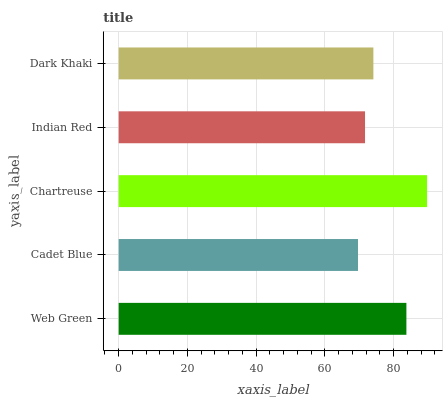Is Cadet Blue the minimum?
Answer yes or no. Yes. Is Chartreuse the maximum?
Answer yes or no. Yes. Is Chartreuse the minimum?
Answer yes or no. No. Is Cadet Blue the maximum?
Answer yes or no. No. Is Chartreuse greater than Cadet Blue?
Answer yes or no. Yes. Is Cadet Blue less than Chartreuse?
Answer yes or no. Yes. Is Cadet Blue greater than Chartreuse?
Answer yes or no. No. Is Chartreuse less than Cadet Blue?
Answer yes or no. No. Is Dark Khaki the high median?
Answer yes or no. Yes. Is Dark Khaki the low median?
Answer yes or no. Yes. Is Web Green the high median?
Answer yes or no. No. Is Indian Red the low median?
Answer yes or no. No. 